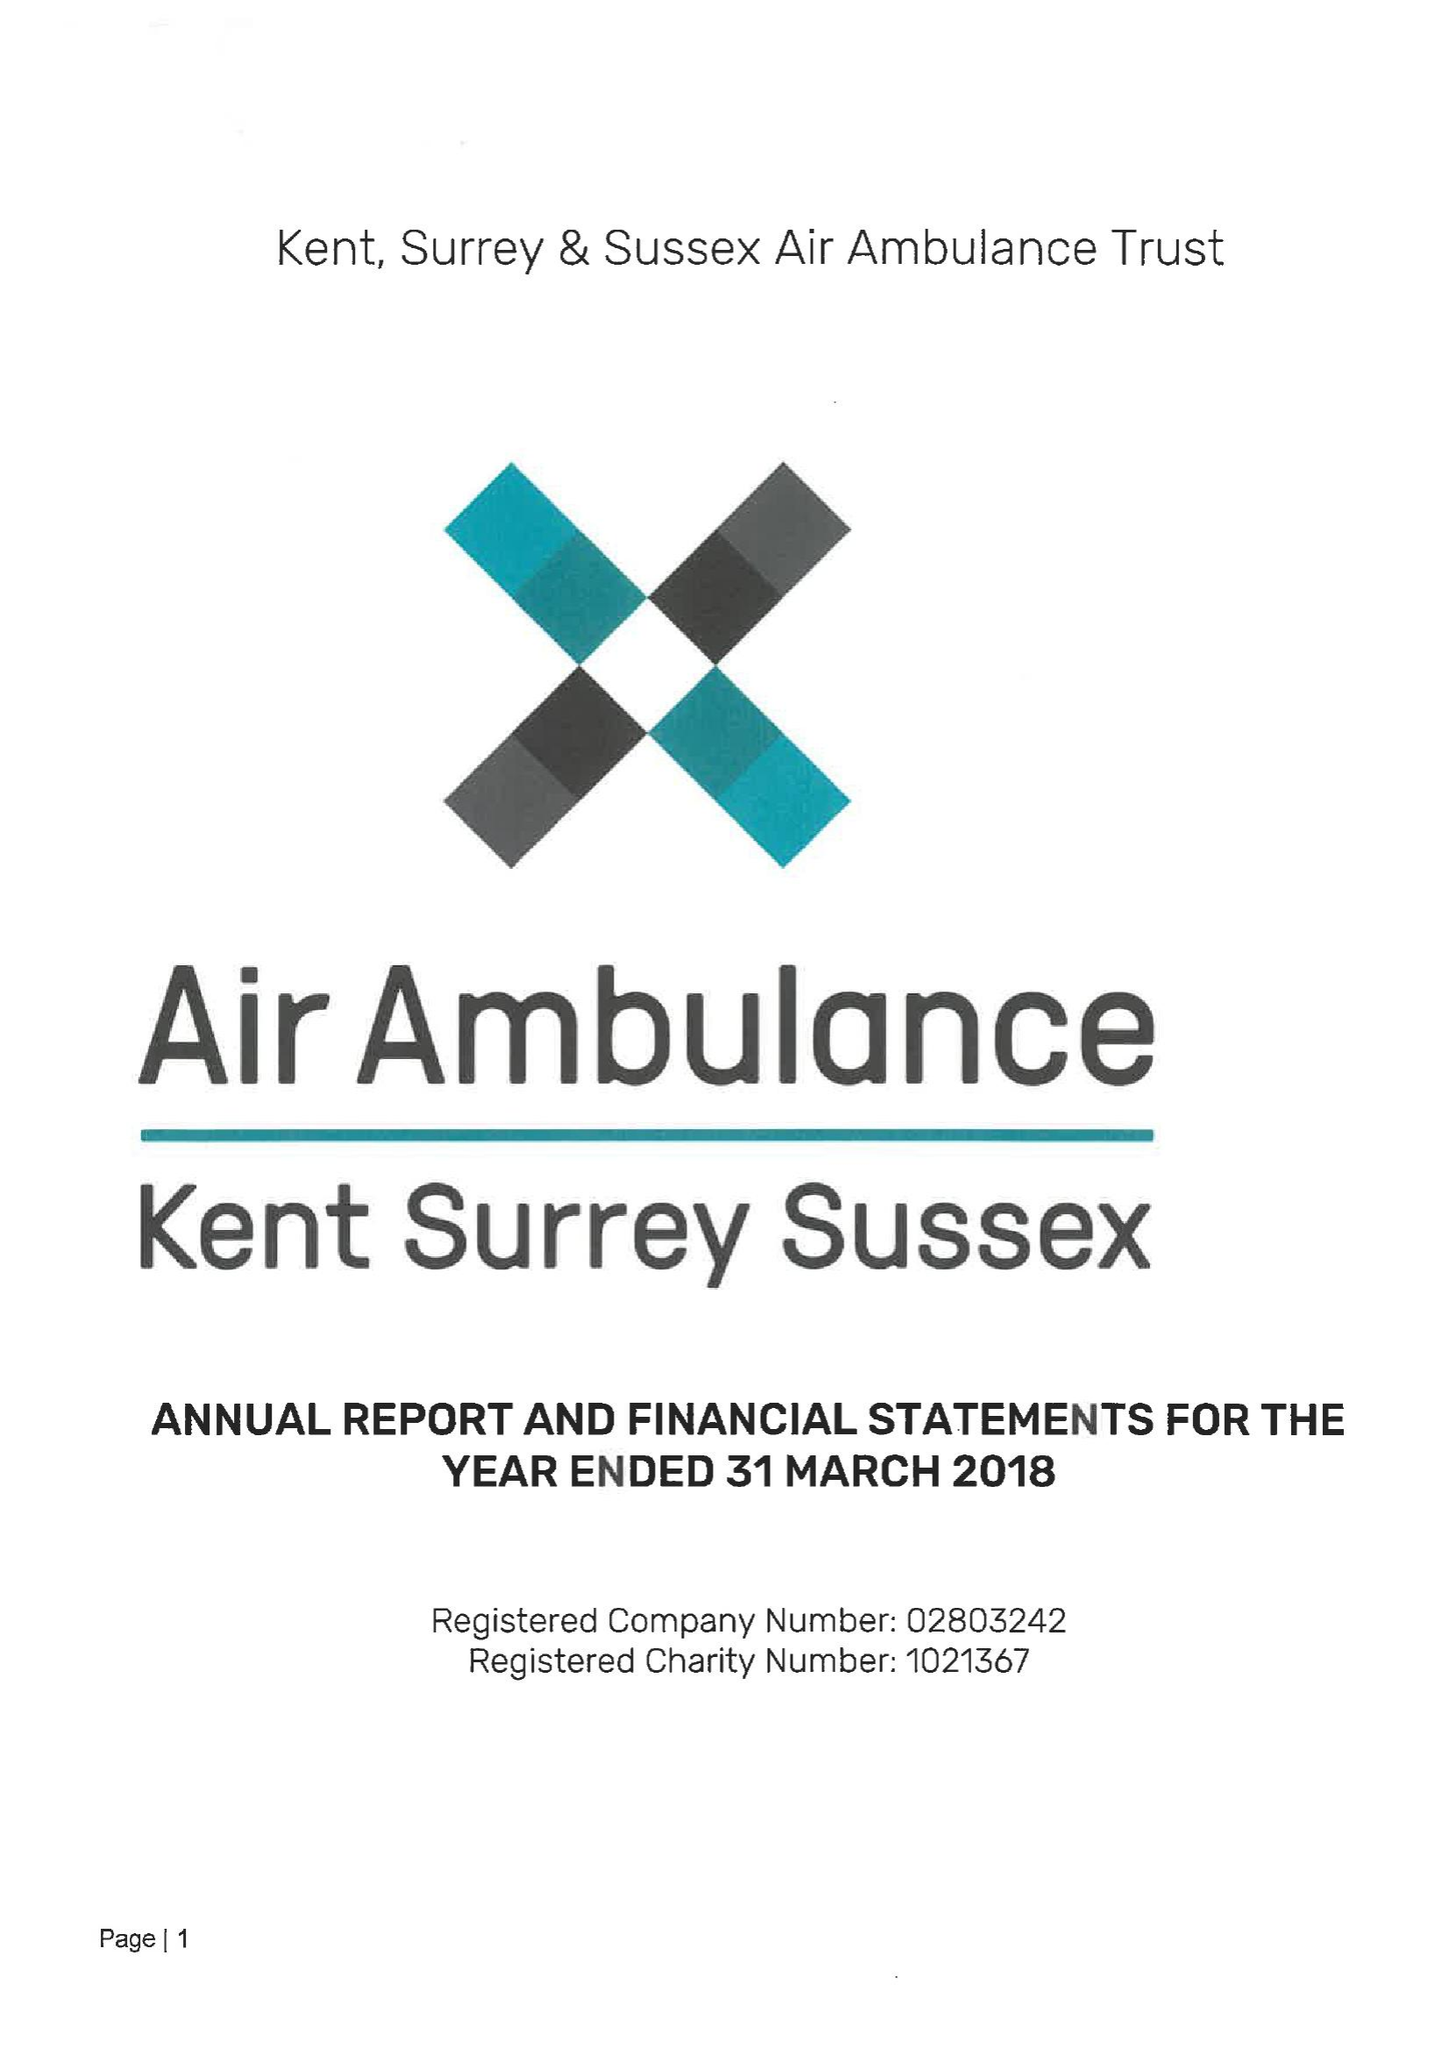What is the value for the address__post_town?
Answer the question using a single word or phrase. CHATHAM 